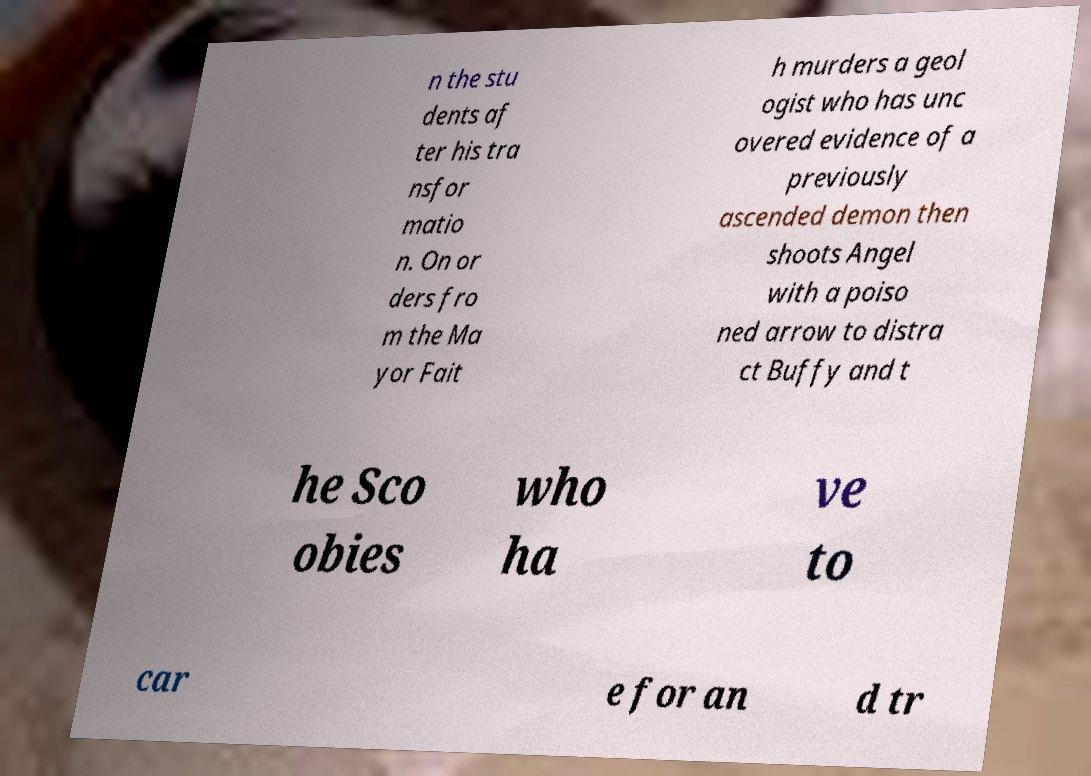Can you accurately transcribe the text from the provided image for me? n the stu dents af ter his tra nsfor matio n. On or ders fro m the Ma yor Fait h murders a geol ogist who has unc overed evidence of a previously ascended demon then shoots Angel with a poiso ned arrow to distra ct Buffy and t he Sco obies who ha ve to car e for an d tr 